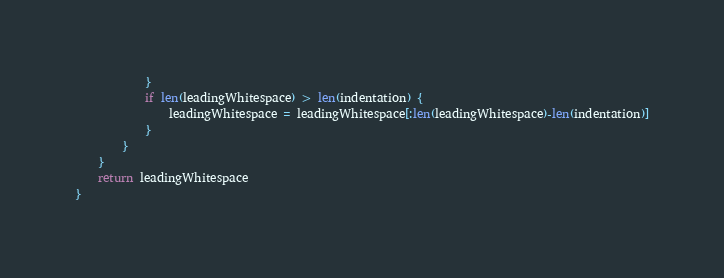Convert code to text. <code><loc_0><loc_0><loc_500><loc_500><_Go_>			}
			if len(leadingWhitespace) > len(indentation) {
				leadingWhitespace = leadingWhitespace[:len(leadingWhitespace)-len(indentation)]
			}
		}
	}
	return leadingWhitespace
}
</code> 